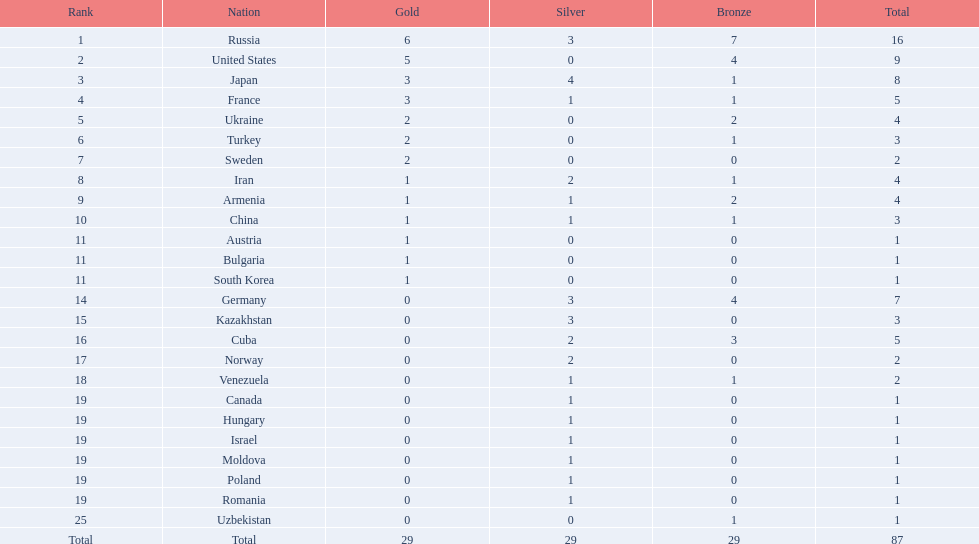How many gold medals did the united states win? 5. Who won more than 5 gold medals? Russia. 